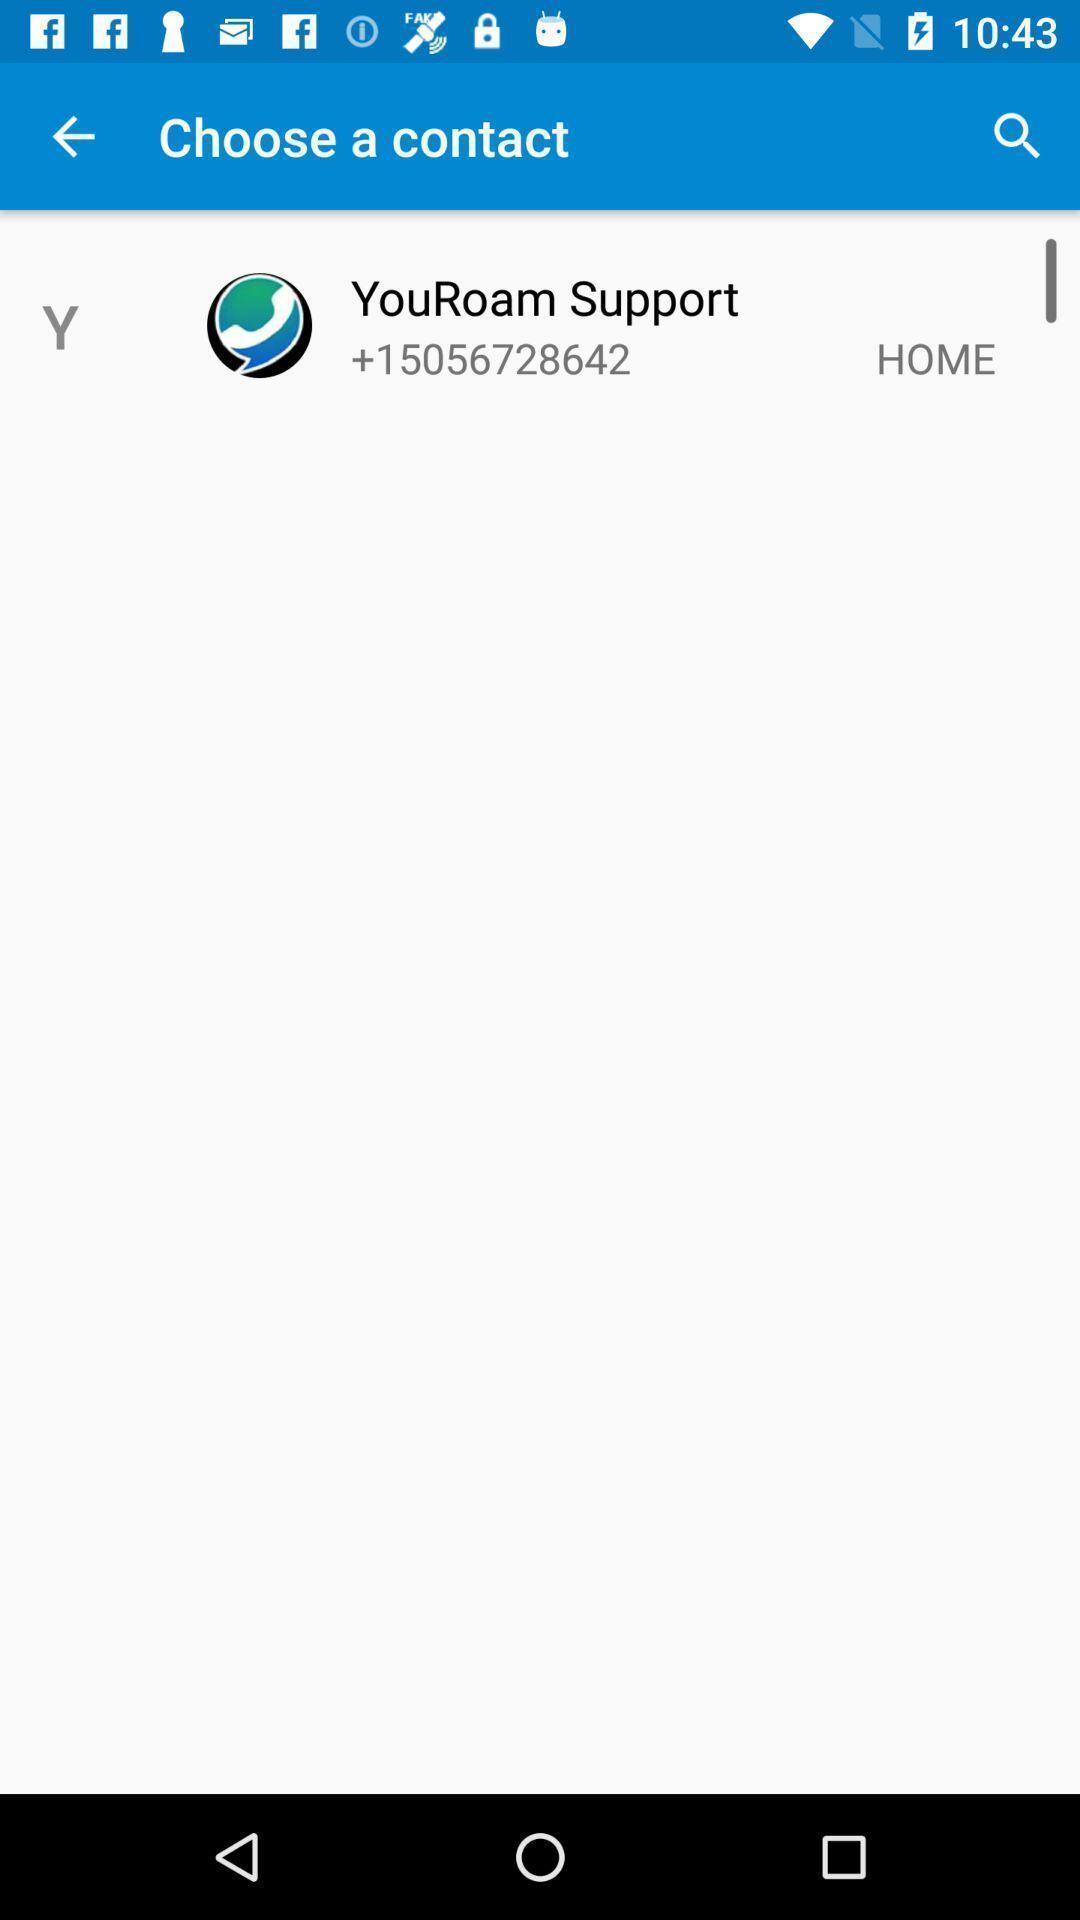Provide a detailed account of this screenshot. You roam support in choose a contact. 